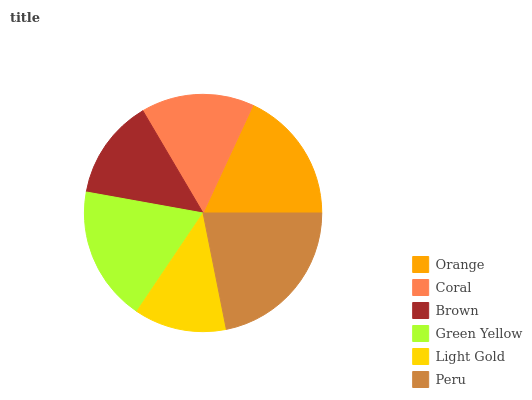Is Light Gold the minimum?
Answer yes or no. Yes. Is Peru the maximum?
Answer yes or no. Yes. Is Coral the minimum?
Answer yes or no. No. Is Coral the maximum?
Answer yes or no. No. Is Orange greater than Coral?
Answer yes or no. Yes. Is Coral less than Orange?
Answer yes or no. Yes. Is Coral greater than Orange?
Answer yes or no. No. Is Orange less than Coral?
Answer yes or no. No. Is Orange the high median?
Answer yes or no. Yes. Is Coral the low median?
Answer yes or no. Yes. Is Peru the high median?
Answer yes or no. No. Is Green Yellow the low median?
Answer yes or no. No. 